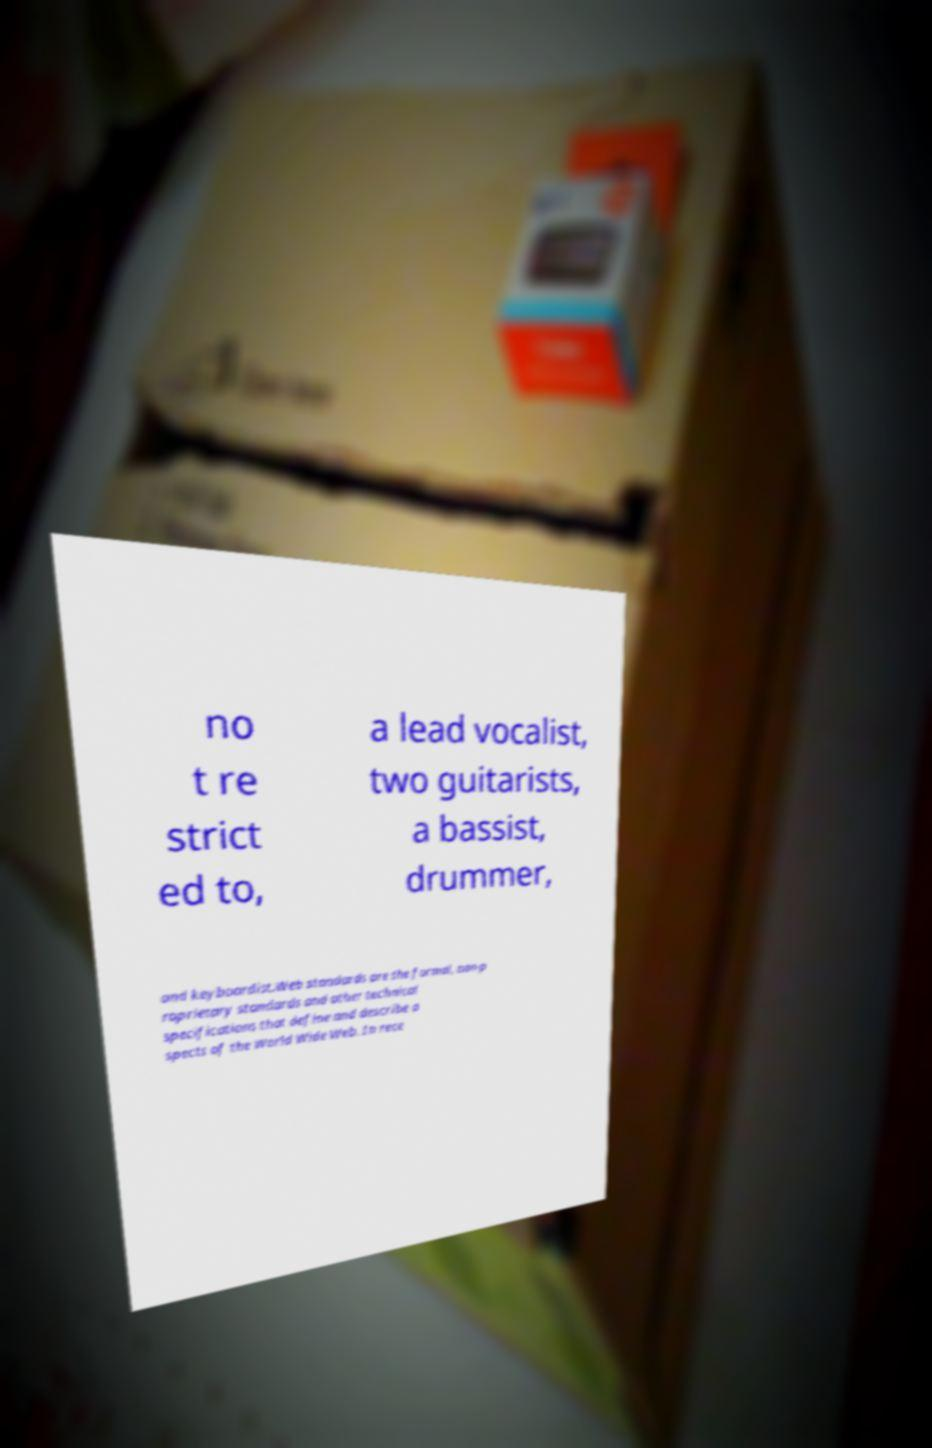Please identify and transcribe the text found in this image. no t re strict ed to, a lead vocalist, two guitarists, a bassist, drummer, and keyboardist.Web standards are the formal, non-p roprietary standards and other technical specifications that define and describe a spects of the World Wide Web. In rece 